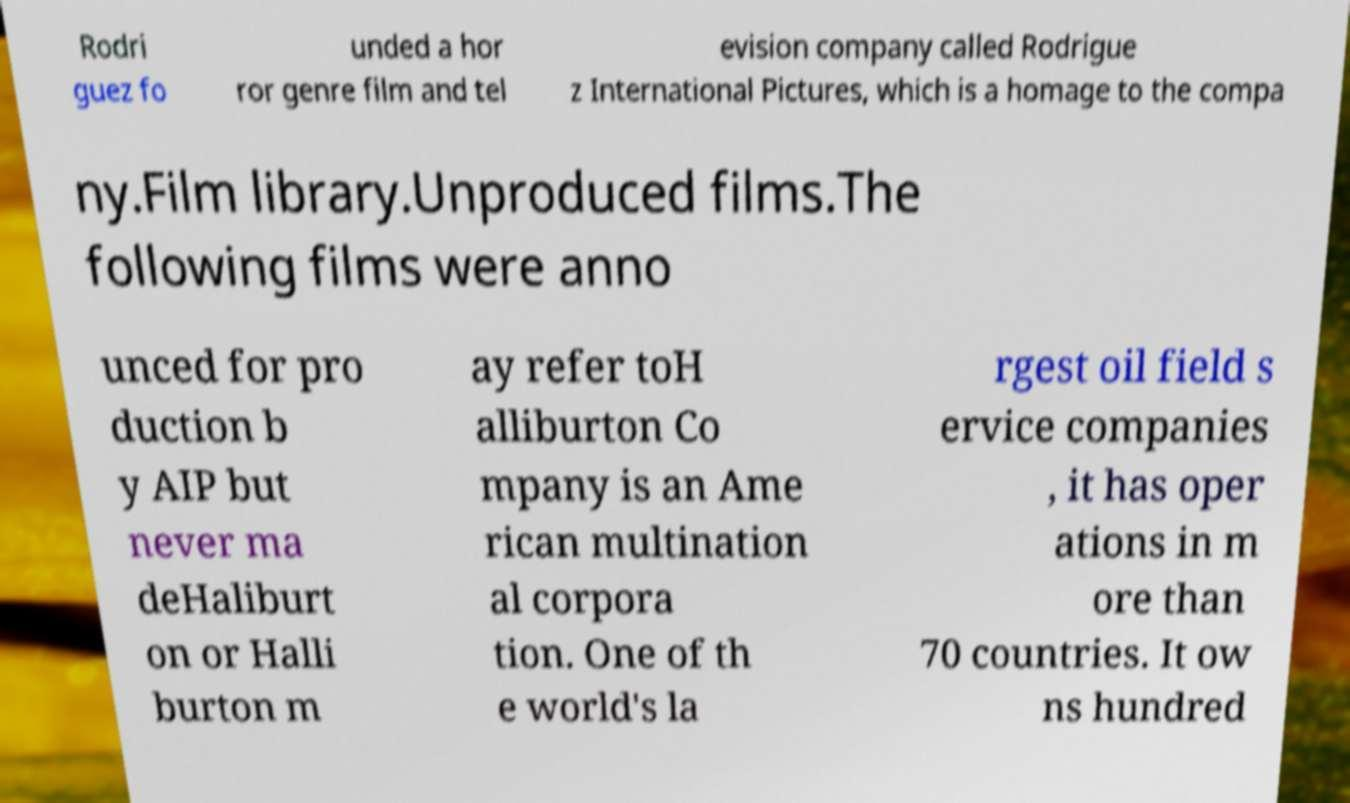Could you extract and type out the text from this image? Rodri guez fo unded a hor ror genre film and tel evision company called Rodrigue z International Pictures, which is a homage to the compa ny.Film library.Unproduced films.The following films were anno unced for pro duction b y AIP but never ma deHaliburt on or Halli burton m ay refer toH alliburton Co mpany is an Ame rican multination al corpora tion. One of th e world's la rgest oil field s ervice companies , it has oper ations in m ore than 70 countries. It ow ns hundred 